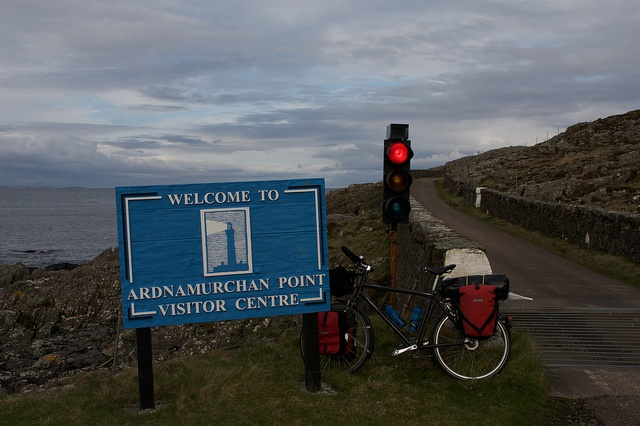Describe the objects in this image and their specific colors. I can see bicycle in gray, black, maroon, and darkgray tones, traffic light in gray, black, red, and brown tones, backpack in gray, maroon, and black tones, and backpack in gray, black, maroon, and darkgray tones in this image. 